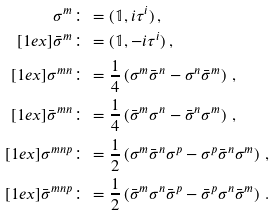<formula> <loc_0><loc_0><loc_500><loc_500>\sigma ^ { m } & \colon = ( \mathbb { 1 } , i \tau ^ { i } ) \, , \\ [ 1 e x ] \bar { \sigma } ^ { m } & \colon = ( \mathbb { 1 } , - i \tau ^ { i } ) \, , \\ [ 1 e x ] \sigma ^ { m n } & \colon = \frac { 1 } { 4 } \left ( \sigma ^ { m } \bar { \sigma } ^ { n } - \sigma ^ { n } \bar { \sigma } ^ { m } \right ) \, , \\ [ 1 e x ] \bar { \sigma } ^ { m n } & \colon = \frac { 1 } { 4 } \left ( \bar { \sigma } ^ { m } \sigma ^ { n } - \bar { \sigma } ^ { n } \sigma ^ { m } \right ) \, , \\ [ 1 e x ] \sigma ^ { m n p } & \colon = \frac { 1 } { 2 } \left ( \sigma ^ { m } \bar { \sigma } ^ { n } \sigma ^ { p } - \sigma ^ { p } \bar { \sigma } ^ { n } \sigma ^ { m } \right ) \, , \\ [ 1 e x ] \bar { \sigma } ^ { m n p } & \colon = \frac { 1 } { 2 } \left ( \bar { \sigma } ^ { m } \sigma ^ { n } \bar { \sigma } ^ { p } - \bar { \sigma } ^ { p } \sigma ^ { n } \bar { \sigma } ^ { m } \right ) \, .</formula> 